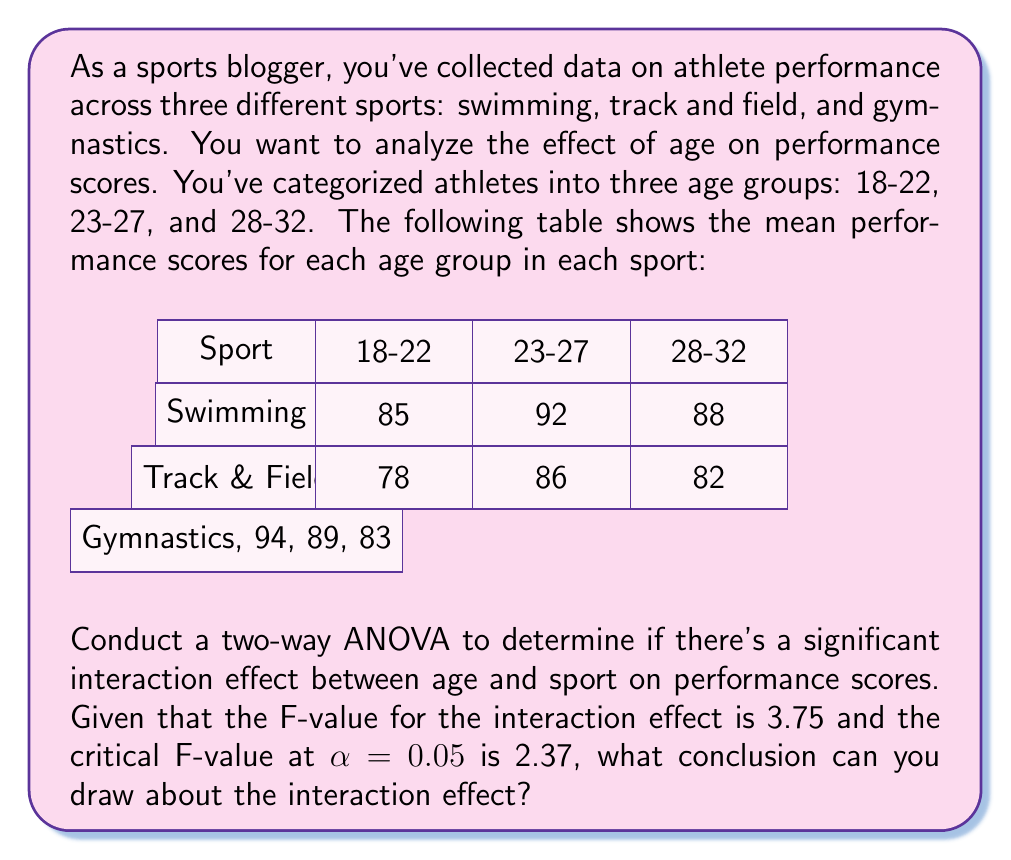Provide a solution to this math problem. To analyze the interaction effect between age and sport on performance scores using a two-way ANOVA, we need to compare the calculated F-value with the critical F-value.

Step 1: Identify the null and alternative hypotheses
H₀: There is no significant interaction effect between age and sport on performance scores.
H₁: There is a significant interaction effect between age and sport on performance scores.

Step 2: Compare the F-value with the critical F-value
Calculated F-value for interaction effect: 3.75
Critical F-value at α = 0.05: 2.37

Step 3: Decision rule
If the calculated F-value > critical F-value, reject the null hypothesis.
If the calculated F-value ≤ critical F-value, fail to reject the null hypothesis.

Step 4: Make the decision
Since 3.75 > 2.37, we reject the null hypothesis.

Step 5: Interpret the result
Rejecting the null hypothesis means that there is sufficient evidence to conclude that there is a significant interaction effect between age and sport on performance scores.

This interaction effect suggests that the impact of age on performance scores differs across the three sports. For example, in swimming and track & field, performance peaks in the 23-27 age group, while in gymnastics, performance decreases with age. This finding is particularly relevant for a sports blogger, as it highlights the complex relationship between age and performance across different sports.
Answer: Significant interaction effect between age and sport on performance scores (F = 3.75 > F_crit = 2.37, p < 0.05) 